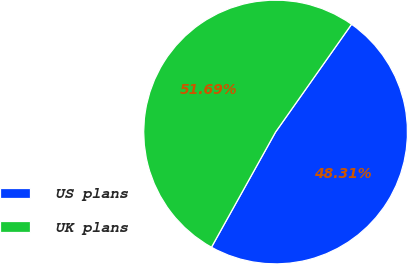Convert chart to OTSL. <chart><loc_0><loc_0><loc_500><loc_500><pie_chart><fcel>US plans<fcel>UK plans<nl><fcel>48.31%<fcel>51.69%<nl></chart> 